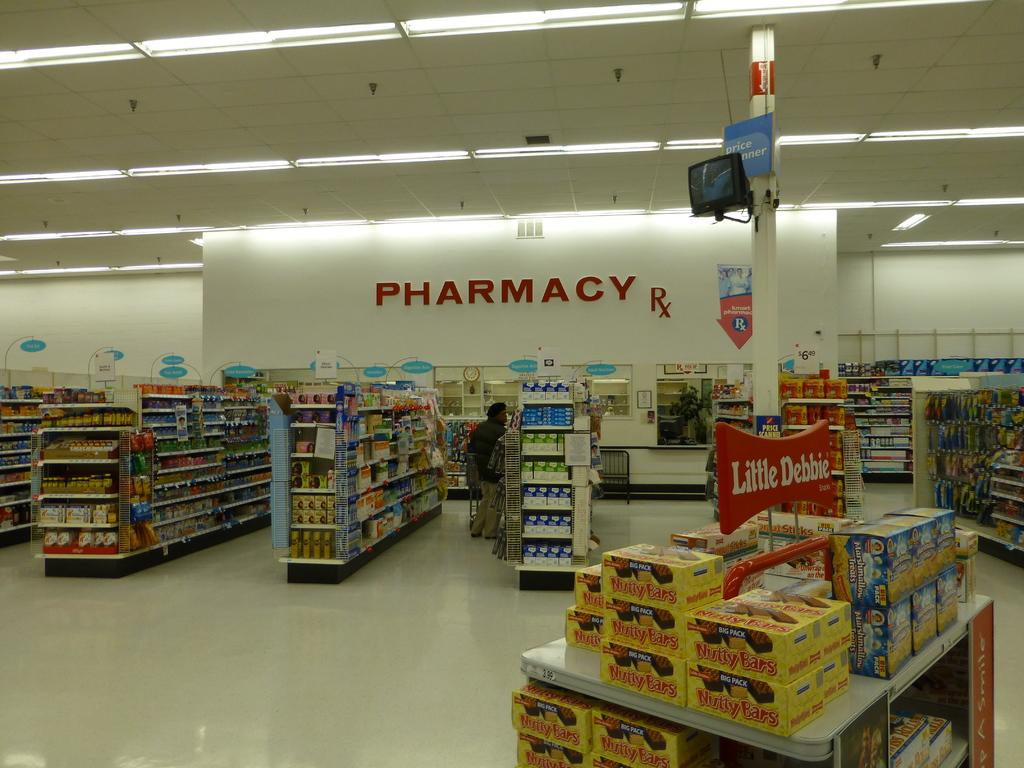<image>
Provide a brief description of the given image. Several aisle of goods in a market with a Pharmacy section. 